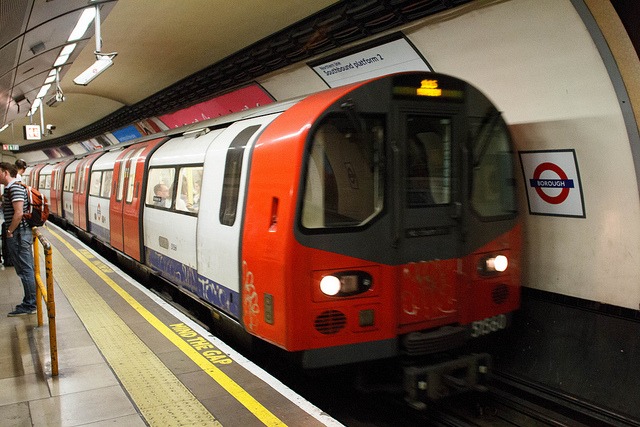Please identify all text content in this image. LOROUGH GAP THE 